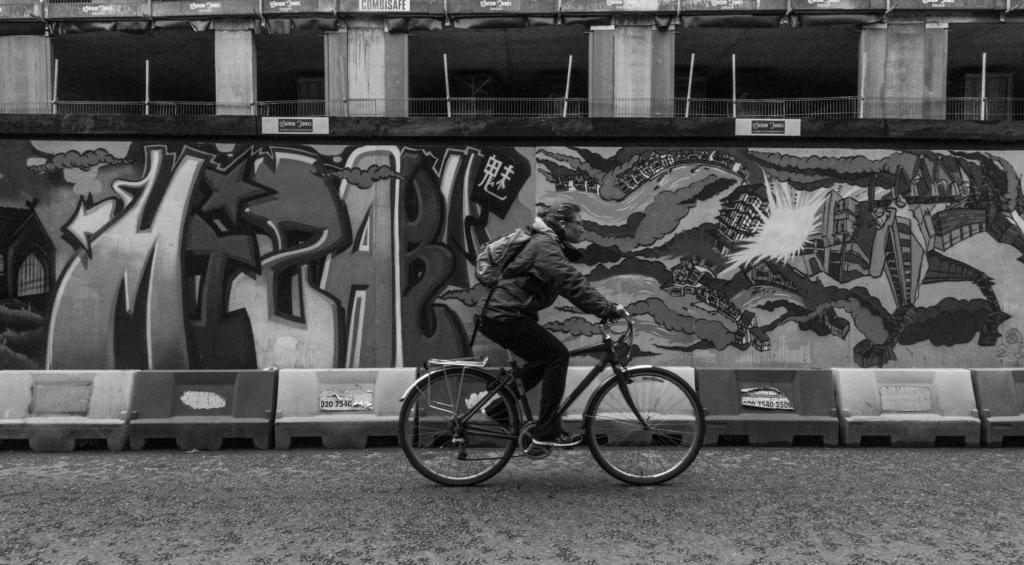Could you give a brief overview of what you see in this image? In the center of the image we can see a person riding a bicycle. In the background there is a wall and we can see a graffiti on the wall. At the bottom there is a road. 